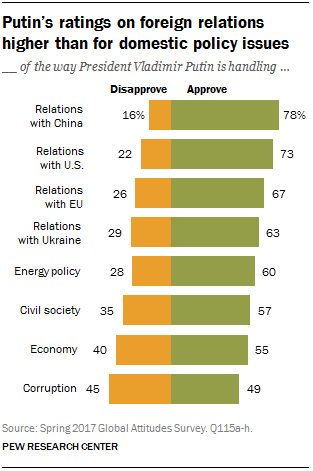Specify some key components in this picture. The value of approving an opinion in the economy is 55. The median of green bars is greater than the largest orange bar. 